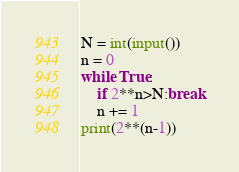Convert code to text. <code><loc_0><loc_0><loc_500><loc_500><_Python_>N = int(input())
n = 0
while True:
	if 2**n>N:break
	n += 1
print(2**(n-1))

</code> 